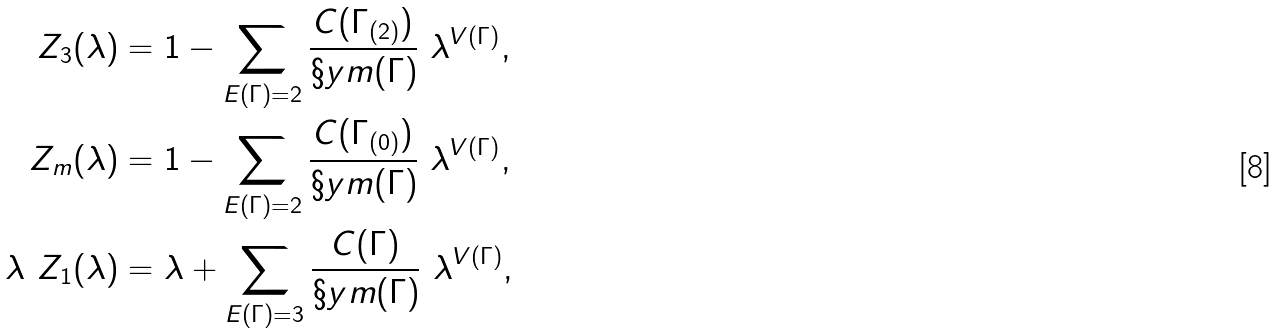<formula> <loc_0><loc_0><loc_500><loc_500>Z _ { 3 } ( \lambda ) & = 1 - \sum _ { E ( \Gamma ) = 2 } \frac { C ( \Gamma _ { ( 2 ) } ) } { \S y m ( \Gamma ) } \ \lambda ^ { V ( \Gamma ) } , \\ Z _ { m } ( \lambda ) & = 1 - \sum _ { E ( \Gamma ) = 2 } \frac { C ( \Gamma _ { ( 0 ) } ) } { \S y m ( \Gamma ) } \ \lambda ^ { V ( \Gamma ) } , \\ \lambda \ Z _ { 1 } ( \lambda ) & = \lambda + \sum _ { E ( \Gamma ) = 3 } \frac { C ( \Gamma ) } { \S y m ( \Gamma ) } \ \lambda ^ { V ( \Gamma ) } ,</formula> 